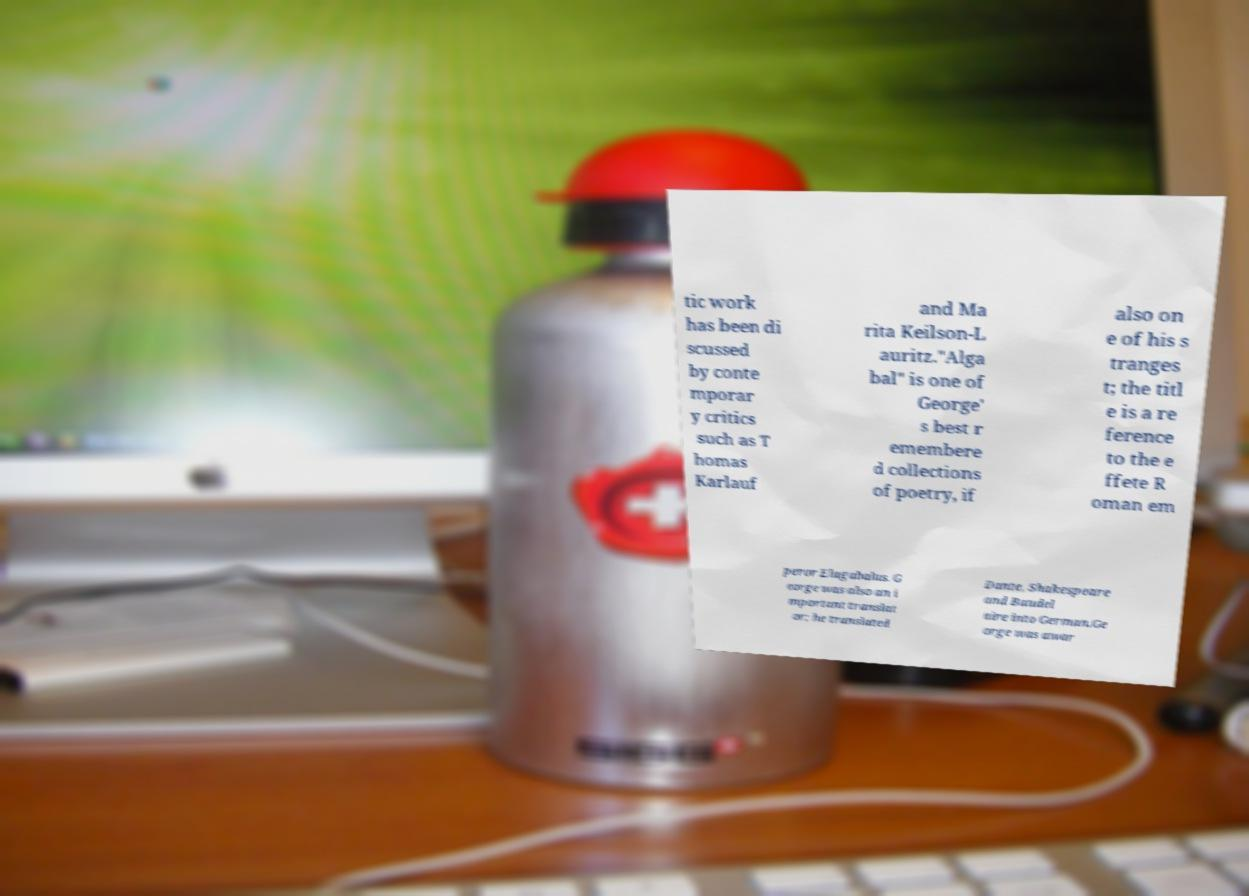What messages or text are displayed in this image? I need them in a readable, typed format. tic work has been di scussed by conte mporar y critics such as T homas Karlauf and Ma rita Keilson-L auritz."Alga bal" is one of George' s best r emembere d collections of poetry, if also on e of his s tranges t; the titl e is a re ference to the e ffete R oman em peror Elagabalus. G eorge was also an i mportant translat or; he translated Dante, Shakespeare and Baudel aire into German.Ge orge was awar 